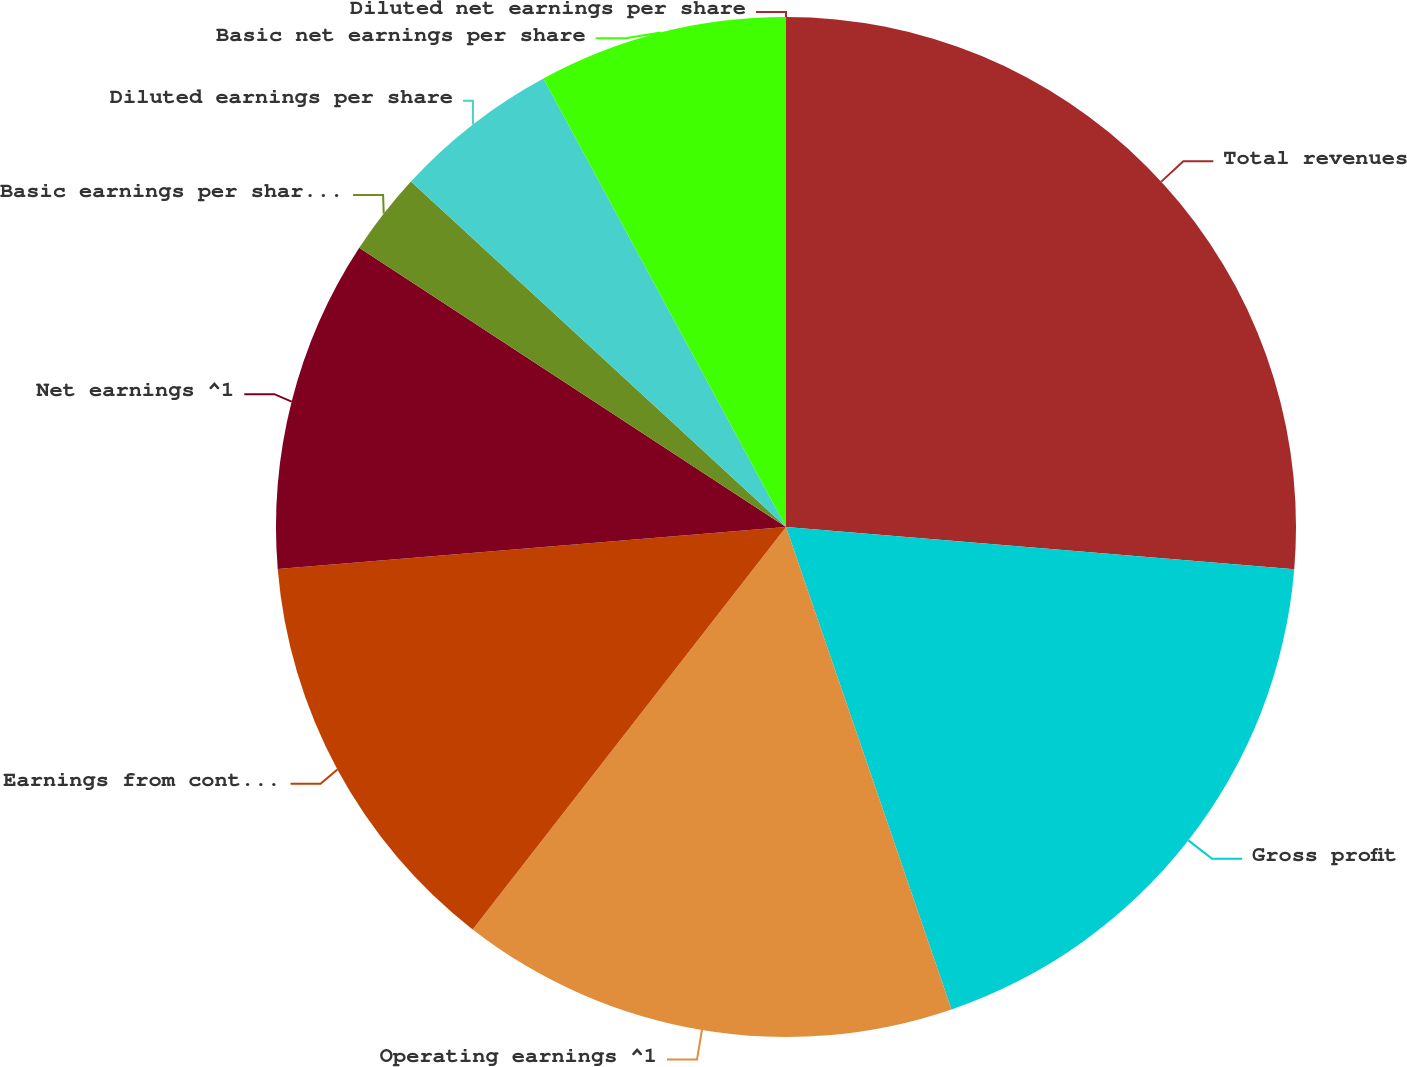Convert chart to OTSL. <chart><loc_0><loc_0><loc_500><loc_500><pie_chart><fcel>Total revenues<fcel>Gross profit<fcel>Operating earnings ^1<fcel>Earnings from continuing<fcel>Net earnings ^1<fcel>Basic earnings per share from<fcel>Diluted earnings per share<fcel>Basic net earnings per share<fcel>Diluted net earnings per share<nl><fcel>26.32%<fcel>18.42%<fcel>15.79%<fcel>13.16%<fcel>10.53%<fcel>2.63%<fcel>5.26%<fcel>7.89%<fcel>0.0%<nl></chart> 